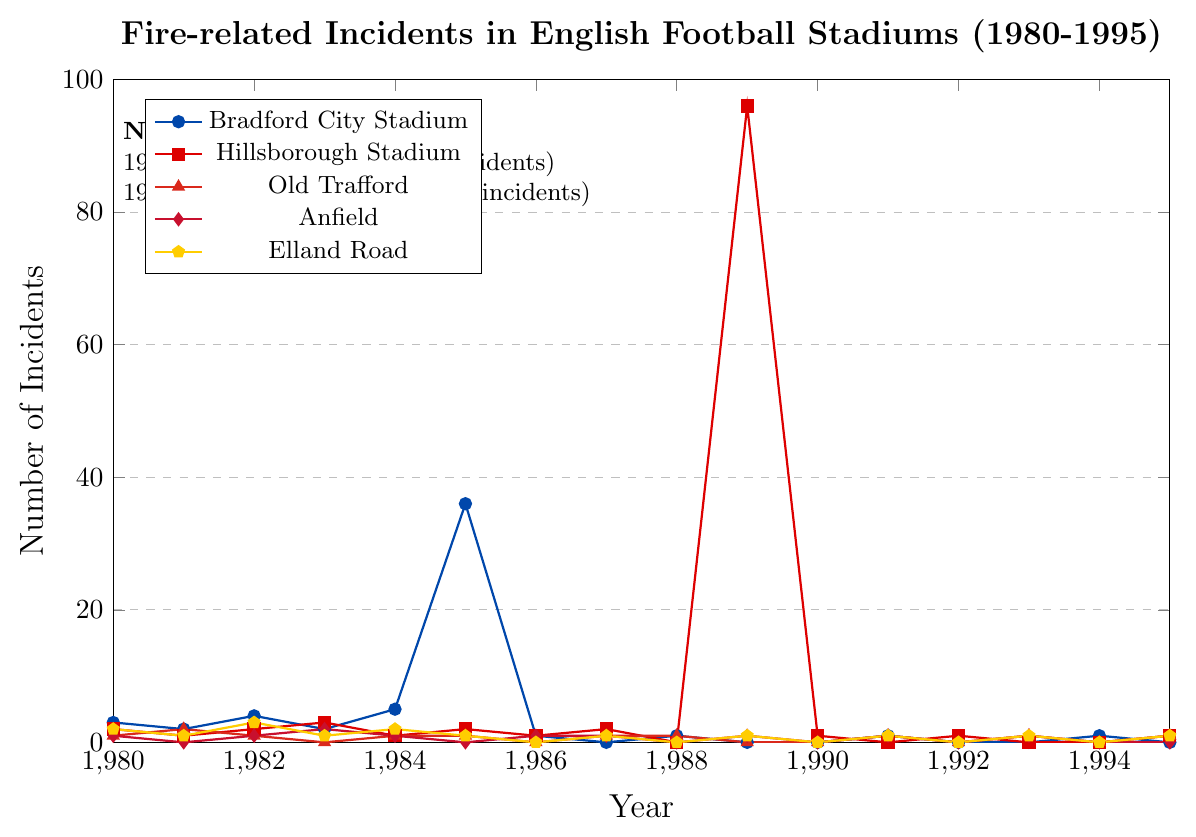How many fire-related incidents were reported at Bradford City Stadium in 1985? Find the data for Bradford City Stadium and look at the value for the year 1985.
Answer: 36 Which stadium had the highest number of incidents in 1989? Look at the values for all the stadiums in 1989 and identify which one is the highest.
Answer: Hillsborough Stadium Between which years did Bradford City Stadium see a drop from 36 to 1 incident? Find the data for Bradford City Stadium and see between which consecutive years the count dropped from 36 to 1.
Answer: 1985 and 1986 Compare the number of incidents at Old Trafford and Elland Road in 1983. Which had more? Look at the values for Old Trafford and Elland Road in 1983 and compare them.
Answer: Elland Road What is the total number of incidents reported at Anfield over the entire period? Add the values for Anfield from 1980 to 1995.
Answer: 10 In which year did Hillsborough Stadium experience a sharp peak in incidents, and what was the number? Identify the year Hillsborough Stadium spiked in incidents and note the corresponding value.
Answer: 1989, 96 Did any stadium report zero incidents in 1990? If so, which? Look up for zero values in 1990 and identify the corresponding stadiums.
Answer: Bradford City Stadium, Old Trafford, Anfield, Elland Road How did the number of incidents at Elland Road change from 1984 to 1985? Compare the values for Elland Road in 1984 and 1985 to see the difference.
Answer: Decreased from 2 to 1 Which stadium had a consistent number of incidents equal to 1 in both 1993 and 1995? Check the data for all the stadiums for the years 1993 and 1995, and find which one had 1 incident in both years.
Answer: Old Trafford 